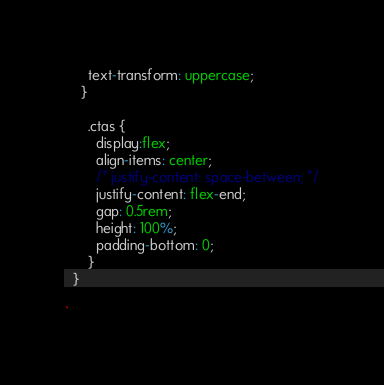<code> <loc_0><loc_0><loc_500><loc_500><_TypeScript_>      text-transform: uppercase;
    }

      .ctas {
        display:flex;
        align-items: center;
        /* justify-content: space-between; */
        justify-content: flex-end;
        gap: 0.5rem;
        height: 100%;
        padding-bottom: 0;
      }
  }

`
</code> 